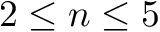<formula> <loc_0><loc_0><loc_500><loc_500>2 \leq n \leq 5</formula> 